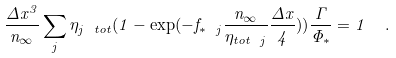Convert formula to latex. <formula><loc_0><loc_0><loc_500><loc_500>\frac { \Delta x ^ { 3 } } { n _ { \infty } } \sum _ { j } \eta _ { j \ t o t } ( 1 - \exp ( - f _ { * \ j } \frac { n _ { \infty } } { \eta _ { t o t \ j } } \frac { \Delta x } { 4 } ) ) \frac { \Gamma } { \Phi _ { * } } = 1 \ \ .</formula> 